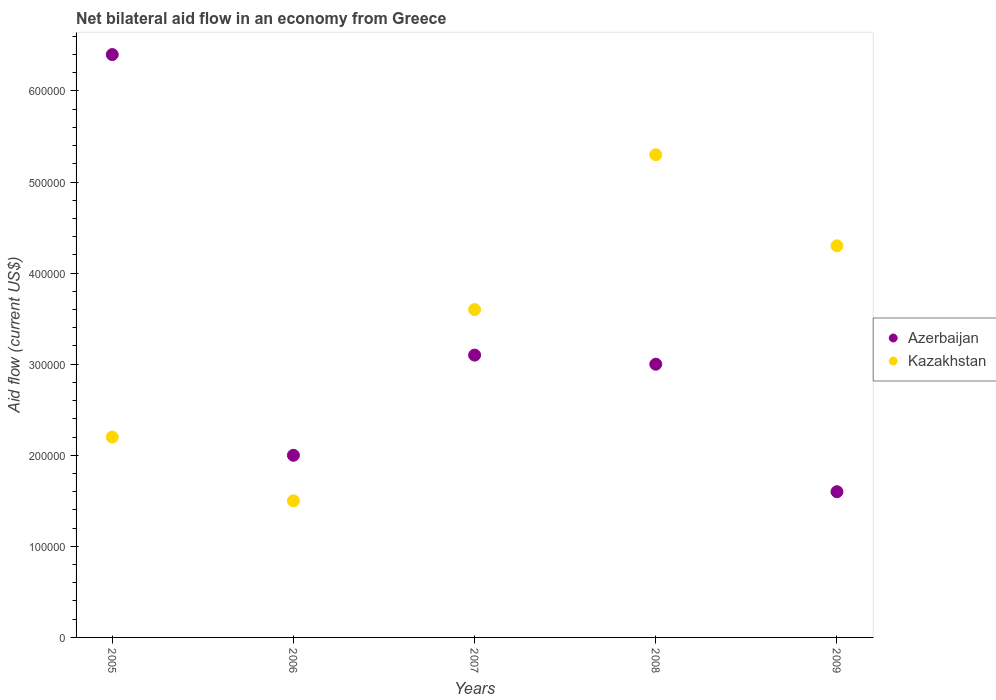How many different coloured dotlines are there?
Keep it short and to the point. 2. Is the number of dotlines equal to the number of legend labels?
Offer a terse response. Yes. What is the net bilateral aid flow in Kazakhstan in 2009?
Keep it short and to the point. 4.30e+05. Across all years, what is the maximum net bilateral aid flow in Kazakhstan?
Your answer should be compact. 5.30e+05. What is the total net bilateral aid flow in Azerbaijan in the graph?
Your answer should be very brief. 1.61e+06. What is the difference between the net bilateral aid flow in Kazakhstan in 2005 and that in 2008?
Offer a terse response. -3.10e+05. What is the difference between the net bilateral aid flow in Kazakhstan in 2005 and the net bilateral aid flow in Azerbaijan in 2007?
Ensure brevity in your answer.  -9.00e+04. What is the average net bilateral aid flow in Kazakhstan per year?
Offer a very short reply. 3.38e+05. In how many years, is the net bilateral aid flow in Azerbaijan greater than 480000 US$?
Provide a short and direct response. 1. What is the ratio of the net bilateral aid flow in Azerbaijan in 2005 to that in 2006?
Offer a terse response. 3.2. Is the net bilateral aid flow in Kazakhstan in 2005 less than that in 2006?
Offer a terse response. No. What is the difference between the highest and the lowest net bilateral aid flow in Kazakhstan?
Keep it short and to the point. 3.80e+05. Is the net bilateral aid flow in Azerbaijan strictly greater than the net bilateral aid flow in Kazakhstan over the years?
Your answer should be compact. No. How many years are there in the graph?
Offer a terse response. 5. Does the graph contain any zero values?
Keep it short and to the point. No. Does the graph contain grids?
Your answer should be compact. No. How many legend labels are there?
Keep it short and to the point. 2. How are the legend labels stacked?
Provide a succinct answer. Vertical. What is the title of the graph?
Keep it short and to the point. Net bilateral aid flow in an economy from Greece. Does "Costa Rica" appear as one of the legend labels in the graph?
Keep it short and to the point. No. What is the label or title of the X-axis?
Your answer should be very brief. Years. What is the label or title of the Y-axis?
Your answer should be compact. Aid flow (current US$). What is the Aid flow (current US$) in Azerbaijan in 2005?
Your response must be concise. 6.40e+05. What is the Aid flow (current US$) in Kazakhstan in 2005?
Provide a short and direct response. 2.20e+05. What is the Aid flow (current US$) in Kazakhstan in 2007?
Your answer should be very brief. 3.60e+05. What is the Aid flow (current US$) in Azerbaijan in 2008?
Provide a short and direct response. 3.00e+05. What is the Aid flow (current US$) of Kazakhstan in 2008?
Make the answer very short. 5.30e+05. What is the Aid flow (current US$) of Azerbaijan in 2009?
Give a very brief answer. 1.60e+05. What is the Aid flow (current US$) of Kazakhstan in 2009?
Offer a terse response. 4.30e+05. Across all years, what is the maximum Aid flow (current US$) in Azerbaijan?
Keep it short and to the point. 6.40e+05. Across all years, what is the maximum Aid flow (current US$) in Kazakhstan?
Provide a short and direct response. 5.30e+05. What is the total Aid flow (current US$) of Azerbaijan in the graph?
Keep it short and to the point. 1.61e+06. What is the total Aid flow (current US$) in Kazakhstan in the graph?
Your response must be concise. 1.69e+06. What is the difference between the Aid flow (current US$) of Azerbaijan in 2005 and that in 2006?
Give a very brief answer. 4.40e+05. What is the difference between the Aid flow (current US$) of Kazakhstan in 2005 and that in 2008?
Offer a terse response. -3.10e+05. What is the difference between the Aid flow (current US$) of Kazakhstan in 2005 and that in 2009?
Offer a very short reply. -2.10e+05. What is the difference between the Aid flow (current US$) in Azerbaijan in 2006 and that in 2007?
Give a very brief answer. -1.10e+05. What is the difference between the Aid flow (current US$) in Azerbaijan in 2006 and that in 2008?
Your answer should be very brief. -1.00e+05. What is the difference between the Aid flow (current US$) in Kazakhstan in 2006 and that in 2008?
Provide a succinct answer. -3.80e+05. What is the difference between the Aid flow (current US$) of Azerbaijan in 2006 and that in 2009?
Provide a short and direct response. 4.00e+04. What is the difference between the Aid flow (current US$) in Kazakhstan in 2006 and that in 2009?
Your answer should be compact. -2.80e+05. What is the difference between the Aid flow (current US$) of Azerbaijan in 2007 and that in 2008?
Your answer should be compact. 10000. What is the difference between the Aid flow (current US$) in Azerbaijan in 2007 and that in 2009?
Your response must be concise. 1.50e+05. What is the difference between the Aid flow (current US$) of Azerbaijan in 2008 and that in 2009?
Ensure brevity in your answer.  1.40e+05. What is the difference between the Aid flow (current US$) of Azerbaijan in 2005 and the Aid flow (current US$) of Kazakhstan in 2006?
Offer a terse response. 4.90e+05. What is the difference between the Aid flow (current US$) of Azerbaijan in 2006 and the Aid flow (current US$) of Kazakhstan in 2007?
Your response must be concise. -1.60e+05. What is the difference between the Aid flow (current US$) of Azerbaijan in 2006 and the Aid flow (current US$) of Kazakhstan in 2008?
Your answer should be very brief. -3.30e+05. What is the difference between the Aid flow (current US$) in Azerbaijan in 2007 and the Aid flow (current US$) in Kazakhstan in 2008?
Your response must be concise. -2.20e+05. What is the difference between the Aid flow (current US$) in Azerbaijan in 2008 and the Aid flow (current US$) in Kazakhstan in 2009?
Your answer should be very brief. -1.30e+05. What is the average Aid flow (current US$) of Azerbaijan per year?
Keep it short and to the point. 3.22e+05. What is the average Aid flow (current US$) in Kazakhstan per year?
Provide a short and direct response. 3.38e+05. In the year 2006, what is the difference between the Aid flow (current US$) of Azerbaijan and Aid flow (current US$) of Kazakhstan?
Offer a very short reply. 5.00e+04. In the year 2007, what is the difference between the Aid flow (current US$) in Azerbaijan and Aid flow (current US$) in Kazakhstan?
Provide a short and direct response. -5.00e+04. In the year 2008, what is the difference between the Aid flow (current US$) of Azerbaijan and Aid flow (current US$) of Kazakhstan?
Provide a succinct answer. -2.30e+05. In the year 2009, what is the difference between the Aid flow (current US$) of Azerbaijan and Aid flow (current US$) of Kazakhstan?
Make the answer very short. -2.70e+05. What is the ratio of the Aid flow (current US$) of Azerbaijan in 2005 to that in 2006?
Keep it short and to the point. 3.2. What is the ratio of the Aid flow (current US$) of Kazakhstan in 2005 to that in 2006?
Keep it short and to the point. 1.47. What is the ratio of the Aid flow (current US$) in Azerbaijan in 2005 to that in 2007?
Offer a very short reply. 2.06. What is the ratio of the Aid flow (current US$) in Kazakhstan in 2005 to that in 2007?
Offer a very short reply. 0.61. What is the ratio of the Aid flow (current US$) in Azerbaijan in 2005 to that in 2008?
Your answer should be compact. 2.13. What is the ratio of the Aid flow (current US$) in Kazakhstan in 2005 to that in 2008?
Offer a terse response. 0.42. What is the ratio of the Aid flow (current US$) of Kazakhstan in 2005 to that in 2009?
Ensure brevity in your answer.  0.51. What is the ratio of the Aid flow (current US$) in Azerbaijan in 2006 to that in 2007?
Offer a terse response. 0.65. What is the ratio of the Aid flow (current US$) in Kazakhstan in 2006 to that in 2007?
Your response must be concise. 0.42. What is the ratio of the Aid flow (current US$) in Kazakhstan in 2006 to that in 2008?
Give a very brief answer. 0.28. What is the ratio of the Aid flow (current US$) of Azerbaijan in 2006 to that in 2009?
Ensure brevity in your answer.  1.25. What is the ratio of the Aid flow (current US$) in Kazakhstan in 2006 to that in 2009?
Offer a very short reply. 0.35. What is the ratio of the Aid flow (current US$) in Kazakhstan in 2007 to that in 2008?
Your answer should be very brief. 0.68. What is the ratio of the Aid flow (current US$) in Azerbaijan in 2007 to that in 2009?
Your response must be concise. 1.94. What is the ratio of the Aid flow (current US$) of Kazakhstan in 2007 to that in 2009?
Offer a very short reply. 0.84. What is the ratio of the Aid flow (current US$) of Azerbaijan in 2008 to that in 2009?
Your answer should be very brief. 1.88. What is the ratio of the Aid flow (current US$) of Kazakhstan in 2008 to that in 2009?
Your response must be concise. 1.23. What is the difference between the highest and the second highest Aid flow (current US$) of Azerbaijan?
Give a very brief answer. 3.30e+05. What is the difference between the highest and the second highest Aid flow (current US$) of Kazakhstan?
Offer a very short reply. 1.00e+05. What is the difference between the highest and the lowest Aid flow (current US$) of Azerbaijan?
Offer a terse response. 4.80e+05. 